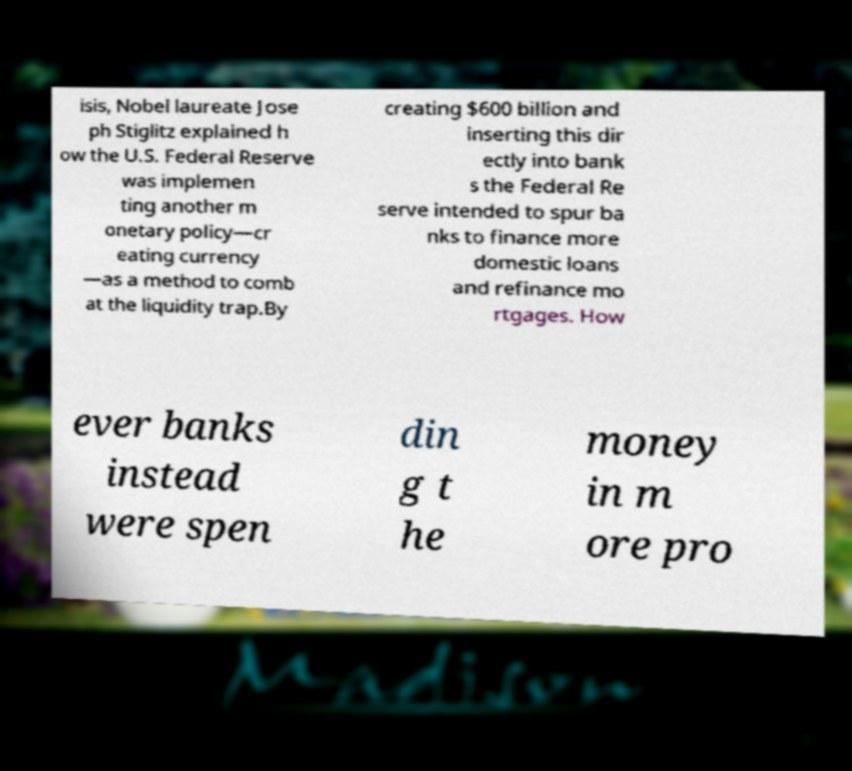Can you accurately transcribe the text from the provided image for me? isis, Nobel laureate Jose ph Stiglitz explained h ow the U.S. Federal Reserve was implemen ting another m onetary policy—cr eating currency —as a method to comb at the liquidity trap.By creating $600 billion and inserting this dir ectly into bank s the Federal Re serve intended to spur ba nks to finance more domestic loans and refinance mo rtgages. How ever banks instead were spen din g t he money in m ore pro 